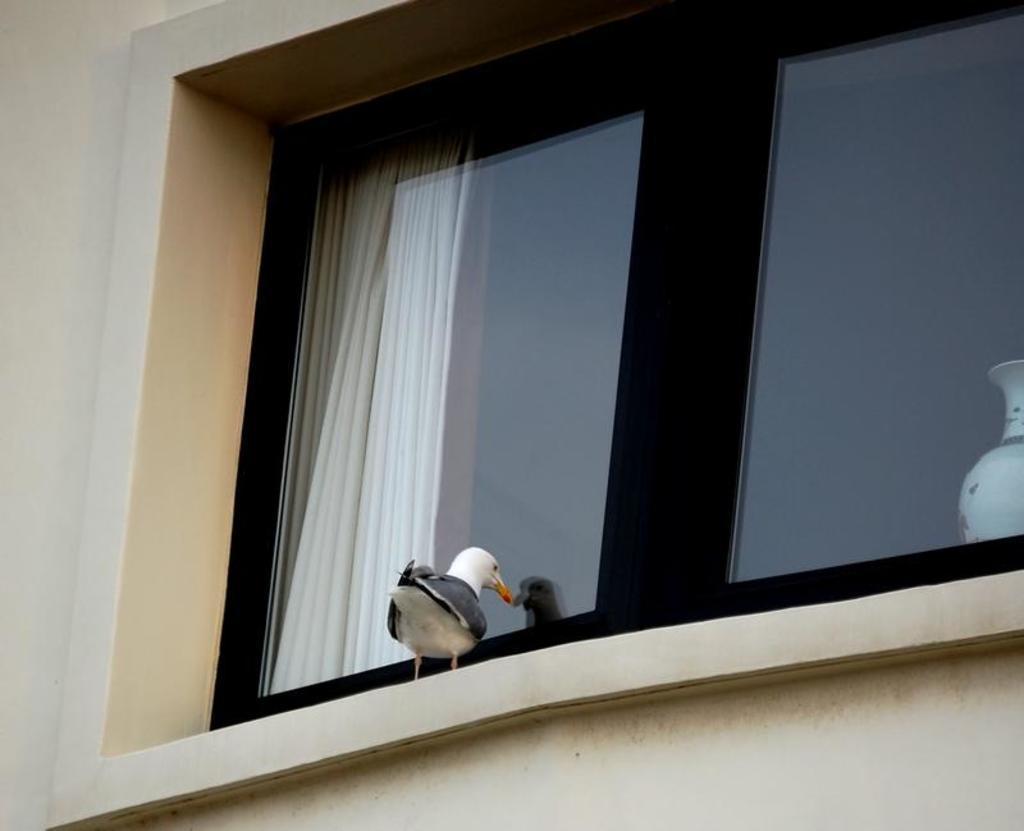In one or two sentences, can you explain what this image depicts? In this image we can see a bird standing near the window, on the left side we can see the wall and on the right side we can see a pot. 